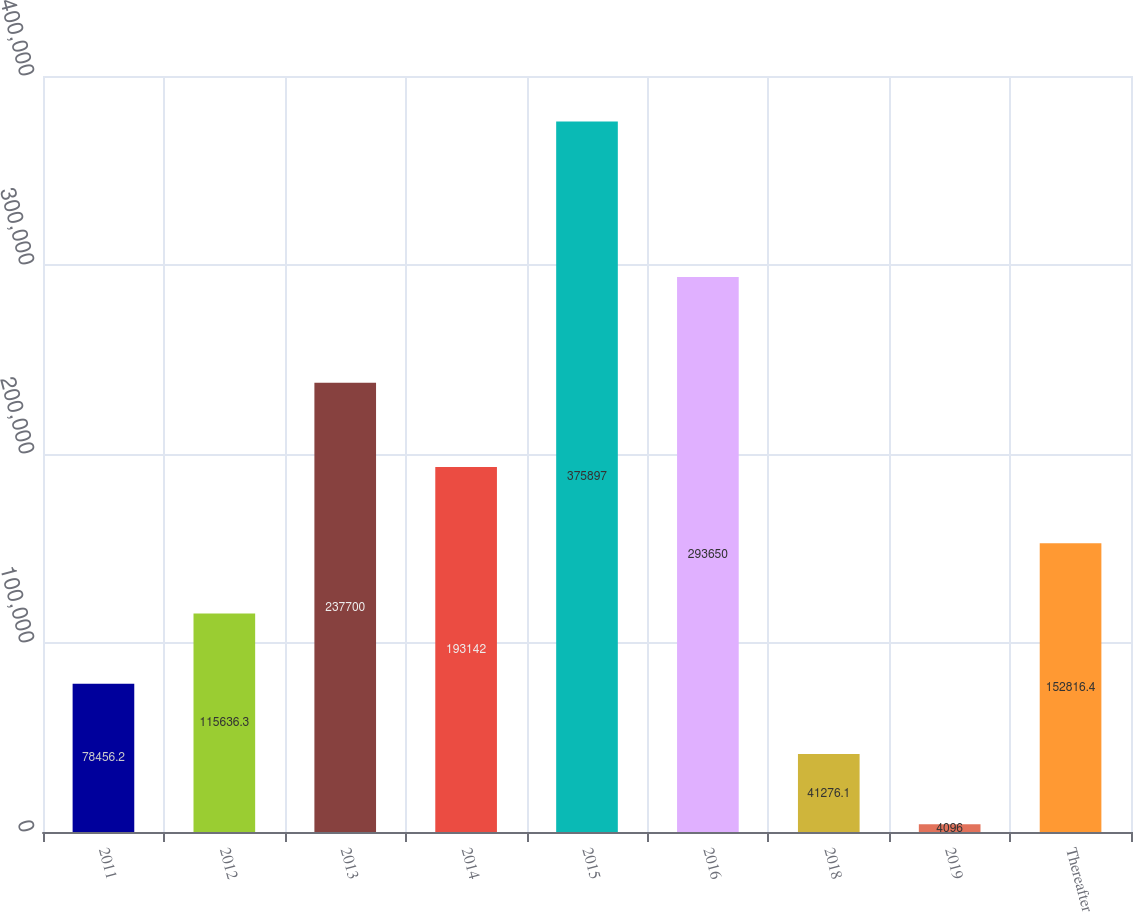Convert chart to OTSL. <chart><loc_0><loc_0><loc_500><loc_500><bar_chart><fcel>2011<fcel>2012<fcel>2013<fcel>2014<fcel>2015<fcel>2016<fcel>2018<fcel>2019<fcel>Thereafter<nl><fcel>78456.2<fcel>115636<fcel>237700<fcel>193142<fcel>375897<fcel>293650<fcel>41276.1<fcel>4096<fcel>152816<nl></chart> 